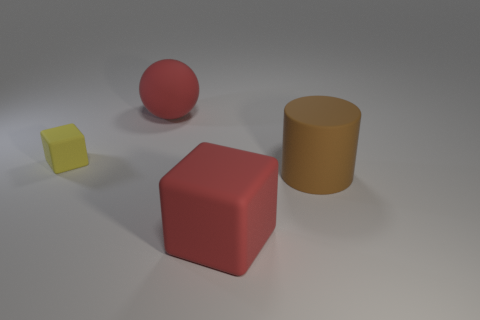There is a matte block that is left of the big red block; what number of blocks are behind it? Observing the spatial arrangement in the image, there appears to be no blocks directly behind the matte block that is positioned to the left of the large red block. 